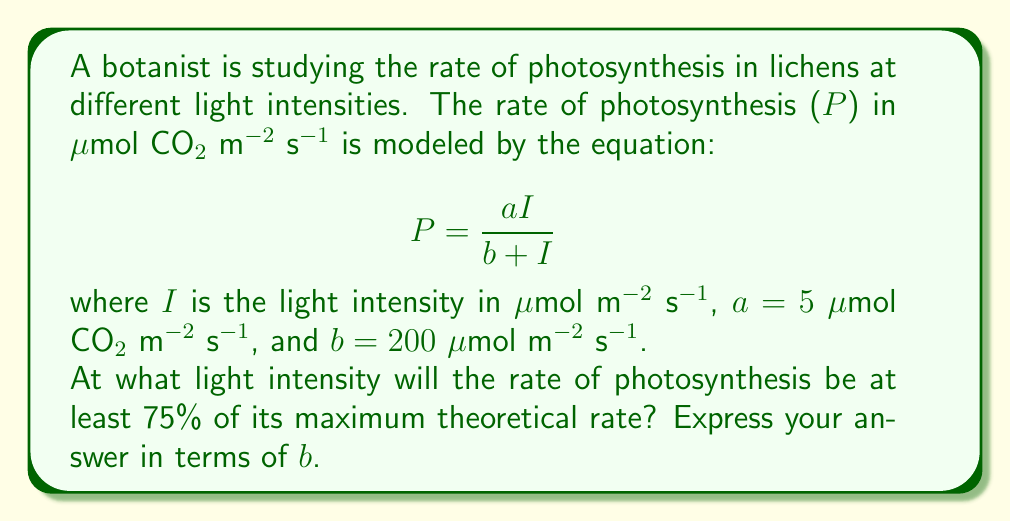Can you answer this question? Let's approach this step-by-step:

1) First, we need to find the maximum theoretical rate of photosynthesis. This occurs when I approaches infinity:

   $P_{max} = \lim_{I \to \infty} \frac{aI}{b + I} = a$

   So, $P_{max} = 5$ μmol CO₂ m⁻² s⁻¹

2) We want to find when P is at least 75% of $P_{max}$:

   $P \geq 0.75P_{max}$
   $\frac{aI}{b + I} \geq 0.75a$

3) Substituting the values:

   $\frac{5I}{200 + I} \geq 0.75(5) = 3.75$

4) Multiply both sides by $(200 + I)$:

   $5I \geq 3.75(200 + I)$
   $5I \geq 750 + 3.75I$

5) Subtract 3.75I from both sides:

   $1.25I \geq 750$

6) Divide both sides by 1.25:

   $I \geq 600$

7) Express in terms of b:

   $I \geq 3b$

Therefore, the light intensity should be at least 3b for the rate of photosynthesis to be at least 75% of its maximum theoretical rate.
Answer: $I \geq 3b$ 